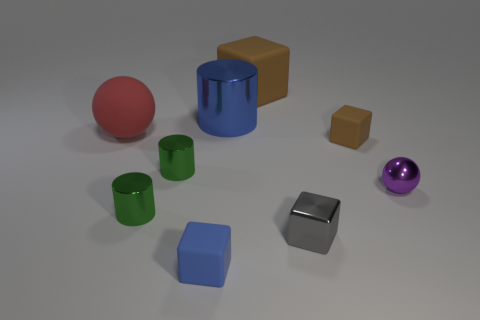There is a ball that is to the left of the rubber object in front of the tiny metallic block; what is its material?
Your answer should be compact. Rubber. Are the large red ball and the ball on the right side of the large brown thing made of the same material?
Make the answer very short. No. What number of objects are either blocks that are to the left of the blue cylinder or small brown matte blocks?
Offer a terse response. 2. Is there a rubber object that has the same color as the big cube?
Your answer should be compact. Yes. There is a tiny brown rubber thing; is its shape the same as the brown object behind the big red rubber sphere?
Offer a terse response. Yes. What number of objects are both to the right of the large cylinder and behind the matte ball?
Ensure brevity in your answer.  1. There is a tiny gray object that is the same shape as the small brown object; what is it made of?
Keep it short and to the point. Metal. How big is the shiny object behind the brown matte object in front of the red sphere?
Keep it short and to the point. Large. Are there any large red matte objects?
Ensure brevity in your answer.  Yes. There is a small thing that is both in front of the tiny shiny ball and behind the gray metallic block; what material is it?
Your response must be concise. Metal. 